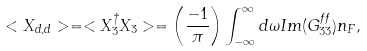Convert formula to latex. <formula><loc_0><loc_0><loc_500><loc_500>< X _ { d , d } > = < X _ { 3 } ^ { \dagger } X _ { 3 } > = \left ( \frac { - 1 } { \pi } \right ) \int _ { - \infty } ^ { \infty } d \omega I m ( G _ { 3 3 } ^ { f f } ) n _ { F } ,</formula> 